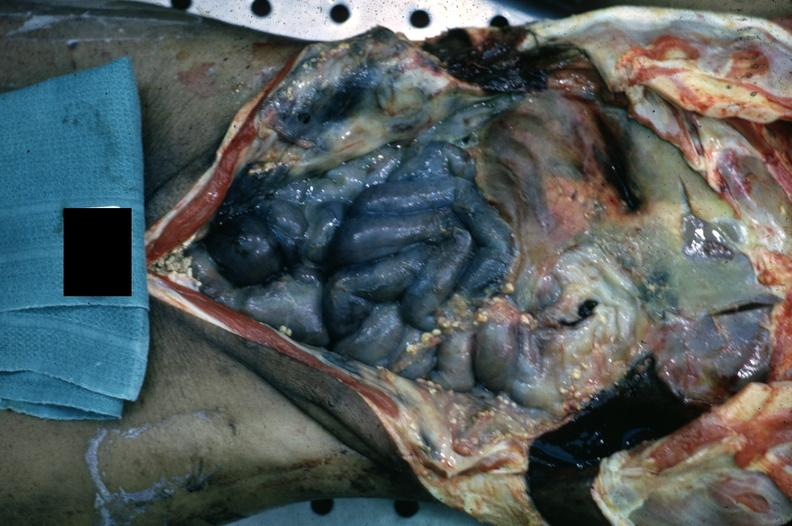what does this image show?
Answer the question using a single word or phrase. Opened body cavity with necrotic bowel and heavy fibrin exudate 